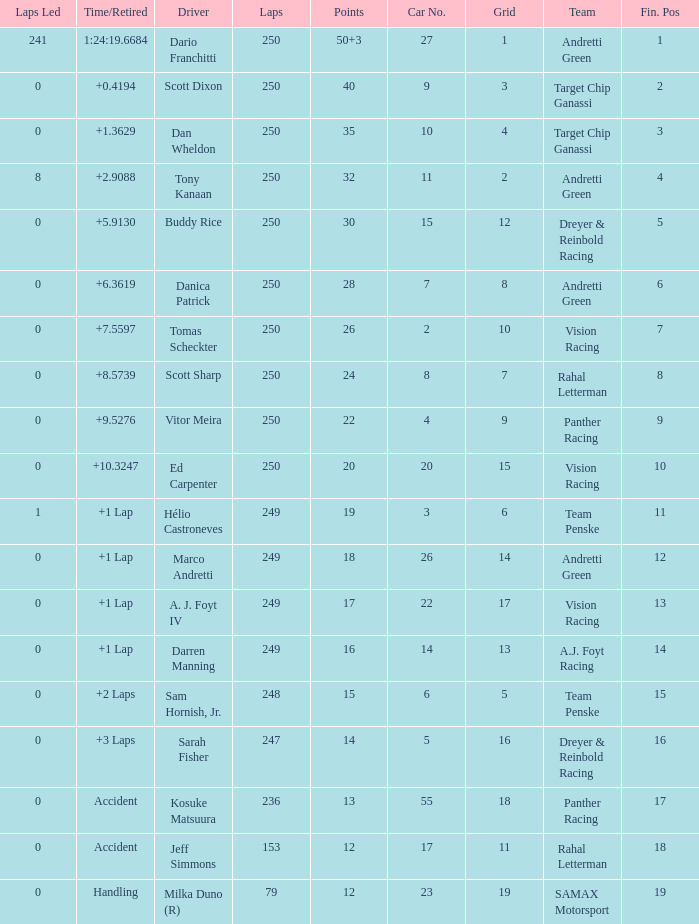Name the total number of fin pos for 12 points of accident 1.0. 